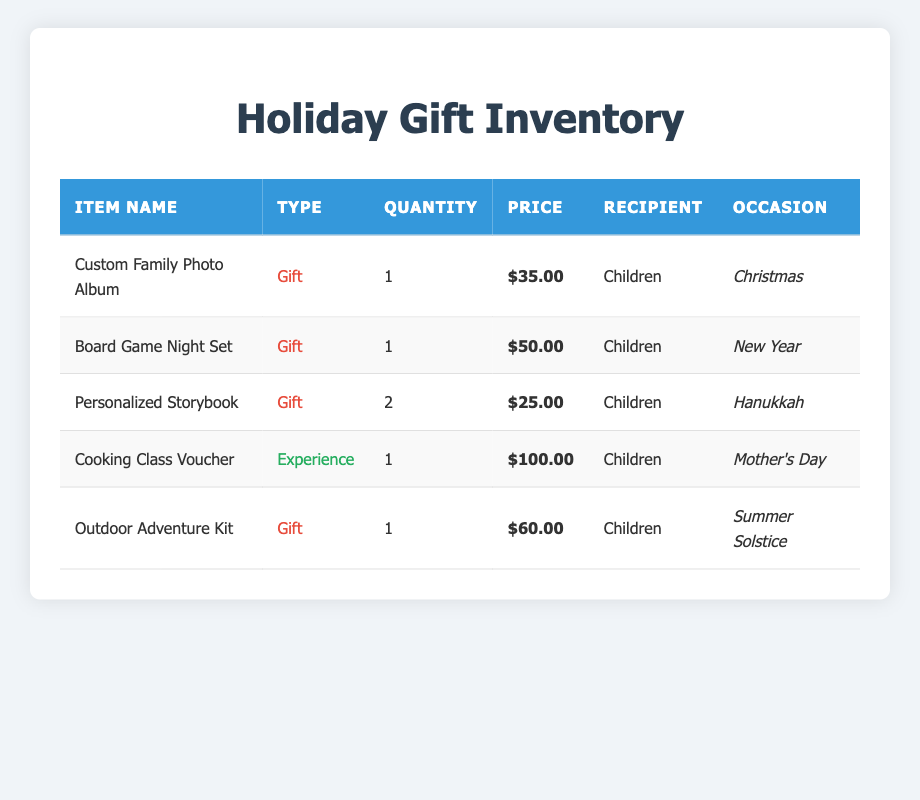What is the total price of all gifts in the inventory? The prices of the gifts are $35.00, $50.00, $25.00 (for two items), $60.00, and $100.00. To find the total, we add them up: $35 + $50 + (2 * $25) + $60 + $100 = $35 + $50 + $50 + $60 + $100 = $295.00.
Answer: $295.00 How many different types of gifts were given? The table lists two types of items: Gift and Experience. There are four items classified as Gift and one item classified as Experience. Thus, there are 2 different types of gifts.
Answer: 2 What gift was given for the occasion of Christmas? Looking at the table, the item listed under the occasion of Christmas is the Custom Family Photo Album.
Answer: Custom Family Photo Album Did the children receive more than one Personalized Storybook? The table indicates that there are 2 Personalized Storybooks listed in the inventory, which means the children did indeed receive more than one.
Answer: Yes What is the price of the Cooking Class Voucher compared to the sum of the prices of the two Personalize Storybooks? The Cooking Class Voucher costs $100.00. The total price of two Personalized Storybooks is 2 * $25.00 = $50.00. Comparing these, $100.00 is greater than $50.00.
Answer: $100.00 is greater What is the average price of all the gifts listed for children? There are five items in total, with the prices being $35.00, $50.00, $25.00, $100.00, and $60.00. The total price sums to $295.00. To find the average, we divide the total price by the number of items: $295.00 / 5 = $59.00.
Answer: $59.00 Which item was intended for the New Year? The table specifies that the Board Game Night Set is designated for the occasion of New Year, making it the correct item for this occasion.
Answer: Board Game Night Set Is there any experience listed as a gift? The table shows that the Cooking Class Voucher is categorized as an Experience and did receive a quantity assigned to it, confirming that experiences are included.
Answer: Yes 